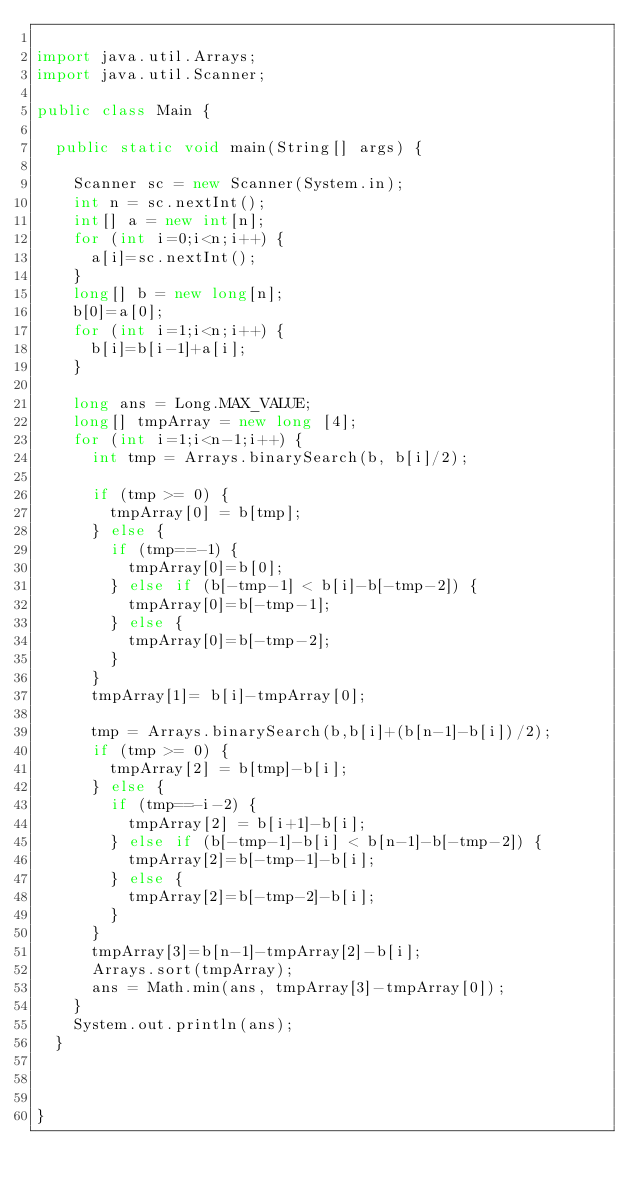Convert code to text. <code><loc_0><loc_0><loc_500><loc_500><_Java_>
import java.util.Arrays;
import java.util.Scanner;

public class Main {

	public static void main(String[] args) {

		Scanner sc = new Scanner(System.in);
		int n = sc.nextInt();
		int[] a = new int[n];
		for (int i=0;i<n;i++) {
			a[i]=sc.nextInt();
		}
		long[] b = new long[n];
		b[0]=a[0];
		for (int i=1;i<n;i++) {
			b[i]=b[i-1]+a[i];
		}

		long ans = Long.MAX_VALUE;
		long[] tmpArray = new long [4];
		for (int i=1;i<n-1;i++) {
			int tmp = Arrays.binarySearch(b, b[i]/2);

			if (tmp >= 0) {
				tmpArray[0] = b[tmp];
			} else {
				if (tmp==-1) {
					tmpArray[0]=b[0];
				} else if (b[-tmp-1] < b[i]-b[-tmp-2]) {
					tmpArray[0]=b[-tmp-1];
				} else {
					tmpArray[0]=b[-tmp-2];
				}
			}
			tmpArray[1]= b[i]-tmpArray[0];

			tmp = Arrays.binarySearch(b,b[i]+(b[n-1]-b[i])/2);
			if (tmp >= 0) {
				tmpArray[2] = b[tmp]-b[i];
			} else {
				if (tmp==-i-2) {
					tmpArray[2] = b[i+1]-b[i];
				} else if (b[-tmp-1]-b[i] < b[n-1]-b[-tmp-2]) {
					tmpArray[2]=b[-tmp-1]-b[i];
				} else {
					tmpArray[2]=b[-tmp-2]-b[i];
				}
			}
			tmpArray[3]=b[n-1]-tmpArray[2]-b[i];
			Arrays.sort(tmpArray);
			ans = Math.min(ans, tmpArray[3]-tmpArray[0]);
		}
		System.out.println(ans);
	}



}
</code> 